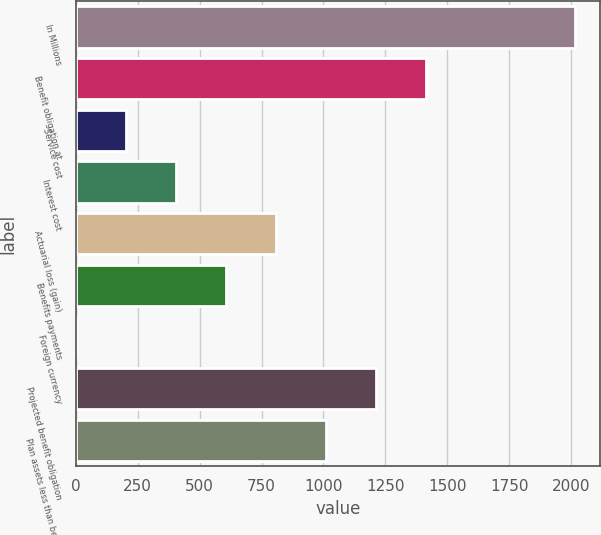Convert chart to OTSL. <chart><loc_0><loc_0><loc_500><loc_500><bar_chart><fcel>In Millions<fcel>Benefit obligation at<fcel>Service cost<fcel>Interest cost<fcel>Actuarial loss (gain)<fcel>Benefits payments<fcel>Foreign currency<fcel>Projected benefit obligation<fcel>Plan assets less than benefit<nl><fcel>2018<fcel>1412.75<fcel>202.25<fcel>404<fcel>807.5<fcel>605.75<fcel>0.5<fcel>1211<fcel>1009.25<nl></chart> 